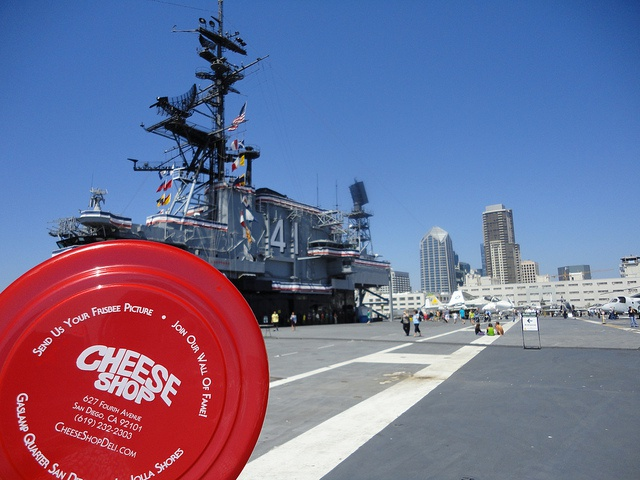Describe the objects in this image and their specific colors. I can see frisbee in blue, brown, and lightgray tones, boat in blue, black, gray, and darkblue tones, people in blue, darkgray, black, gray, and lightgray tones, airplane in blue, lightgray, darkgray, and gray tones, and airplane in blue, lightgray, darkgray, and gray tones in this image. 